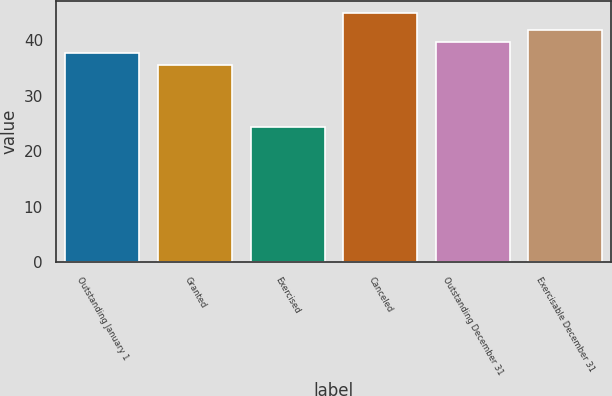Convert chart. <chart><loc_0><loc_0><loc_500><loc_500><bar_chart><fcel>Outstanding January 1<fcel>Granted<fcel>Exercised<fcel>Canceled<fcel>Outstanding December 31<fcel>Exercisable December 31<nl><fcel>37.6<fcel>35.55<fcel>24.28<fcel>44.77<fcel>39.65<fcel>41.7<nl></chart> 